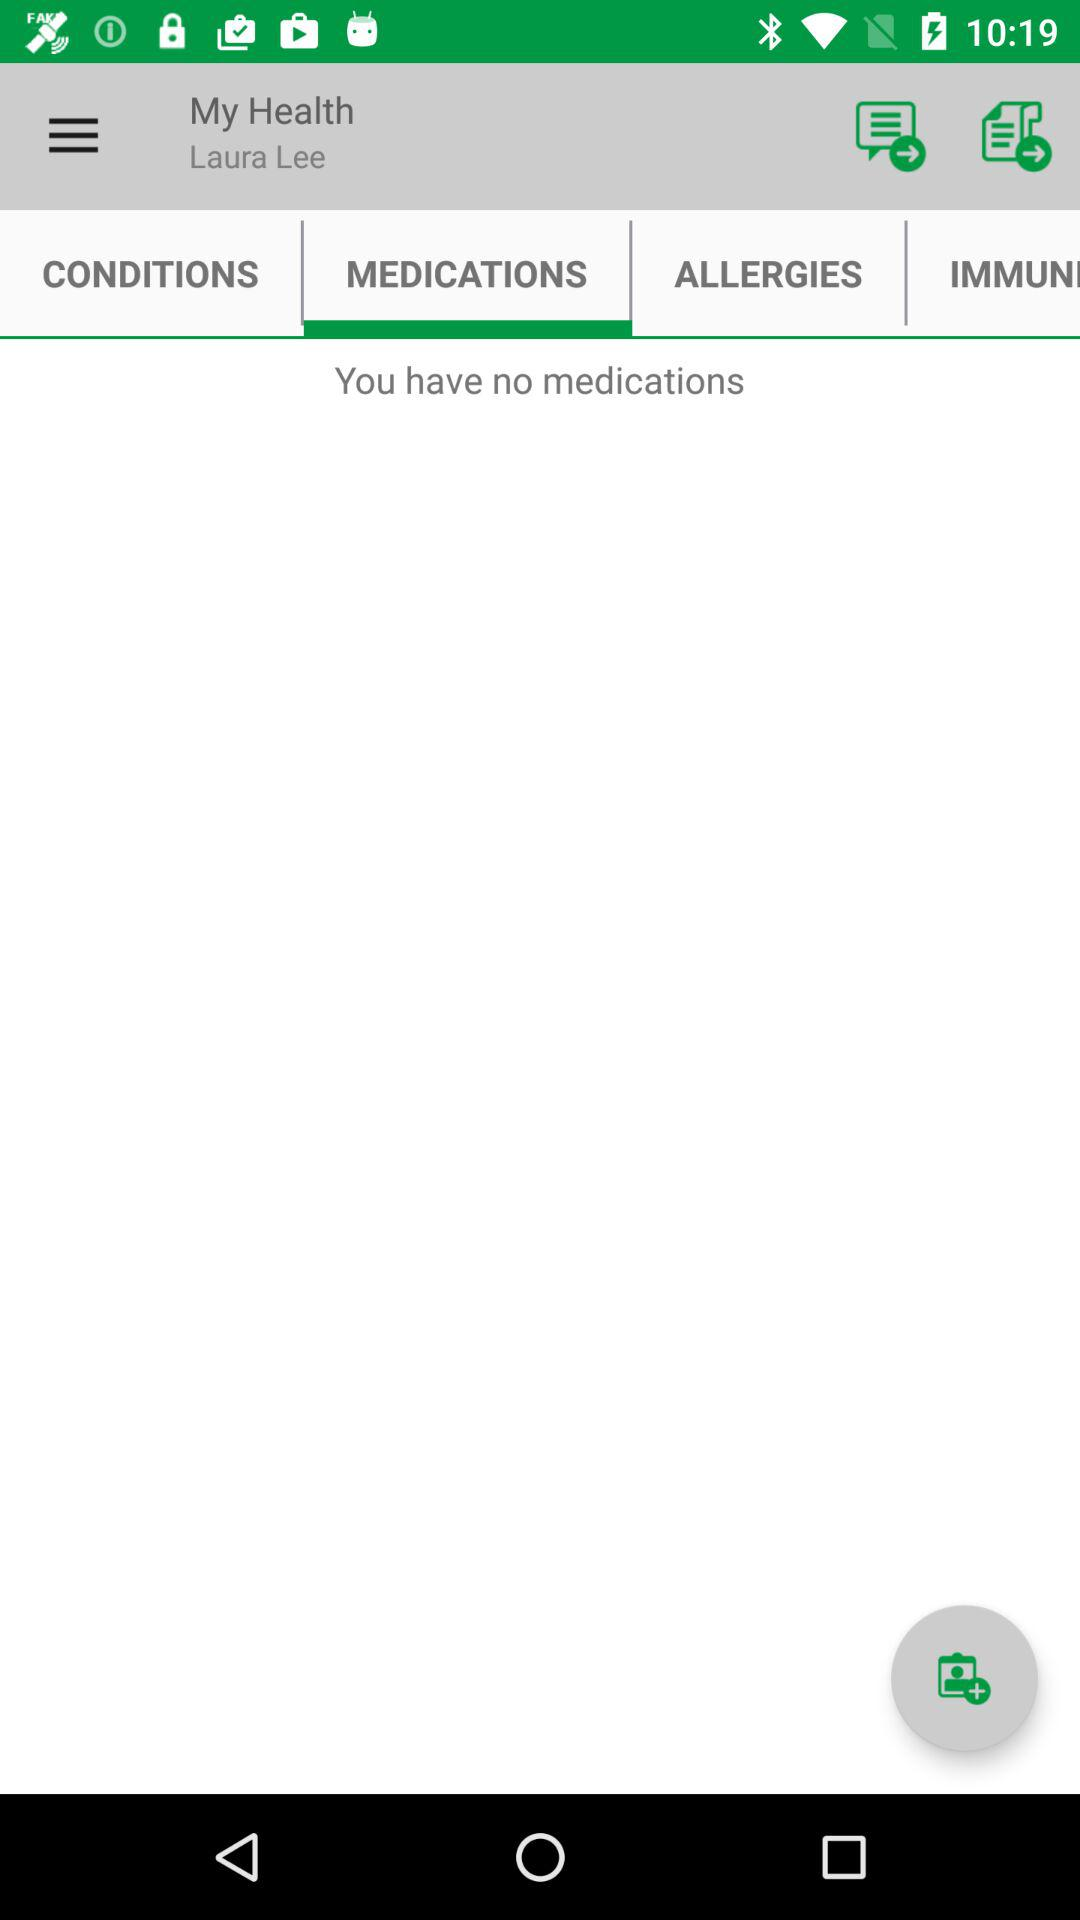Is there any medications? There are no medications. 